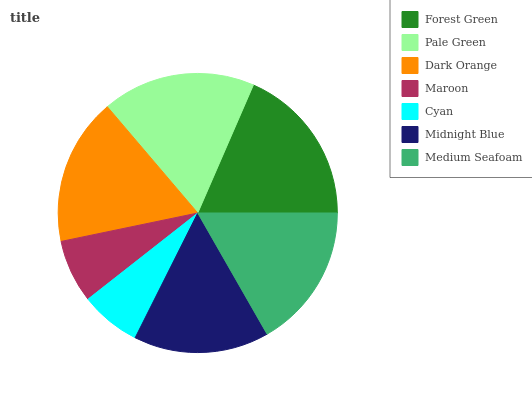Is Cyan the minimum?
Answer yes or no. Yes. Is Forest Green the maximum?
Answer yes or no. Yes. Is Pale Green the minimum?
Answer yes or no. No. Is Pale Green the maximum?
Answer yes or no. No. Is Forest Green greater than Pale Green?
Answer yes or no. Yes. Is Pale Green less than Forest Green?
Answer yes or no. Yes. Is Pale Green greater than Forest Green?
Answer yes or no. No. Is Forest Green less than Pale Green?
Answer yes or no. No. Is Medium Seafoam the high median?
Answer yes or no. Yes. Is Medium Seafoam the low median?
Answer yes or no. Yes. Is Cyan the high median?
Answer yes or no. No. Is Cyan the low median?
Answer yes or no. No. 